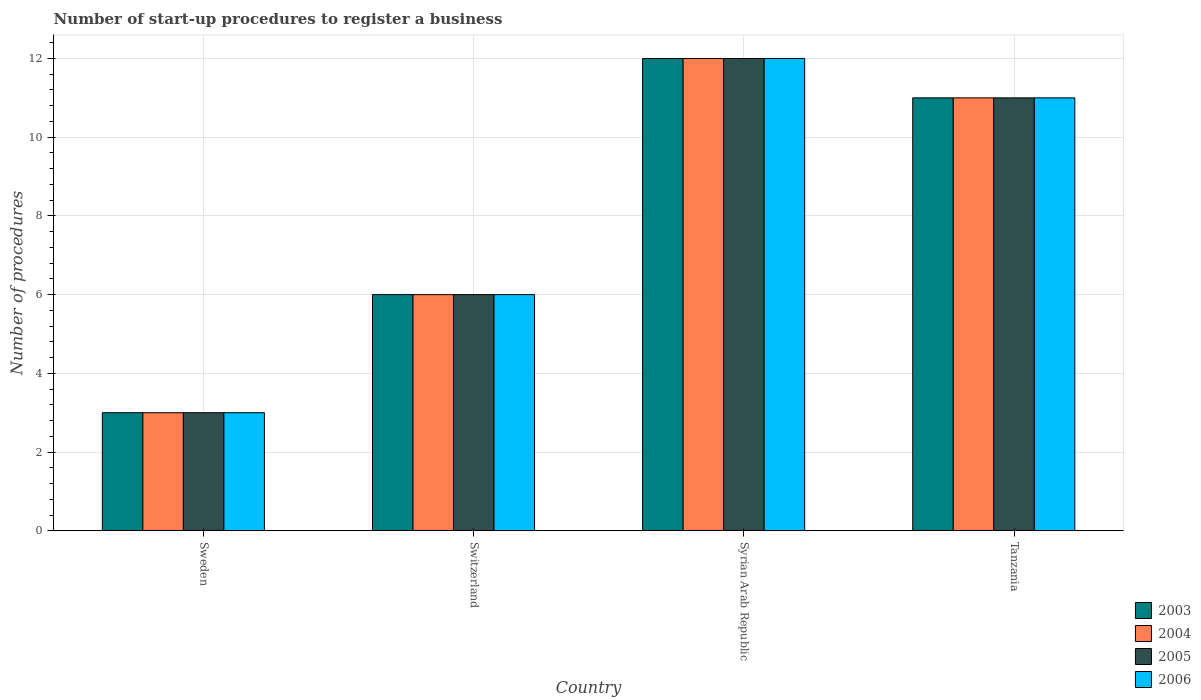Are the number of bars per tick equal to the number of legend labels?
Your answer should be very brief. Yes. How many bars are there on the 4th tick from the right?
Give a very brief answer. 4. What is the label of the 4th group of bars from the left?
Offer a very short reply. Tanzania. In how many cases, is the number of bars for a given country not equal to the number of legend labels?
Make the answer very short. 0. What is the number of procedures required to register a business in 2005 in Syrian Arab Republic?
Provide a succinct answer. 12. Across all countries, what is the maximum number of procedures required to register a business in 2006?
Make the answer very short. 12. In which country was the number of procedures required to register a business in 2005 maximum?
Make the answer very short. Syrian Arab Republic. What is the total number of procedures required to register a business in 2005 in the graph?
Your answer should be compact. 32. What is the difference between the number of procedures required to register a business in 2005 in Tanzania and the number of procedures required to register a business in 2006 in Switzerland?
Your answer should be compact. 5. What is the average number of procedures required to register a business in 2004 per country?
Offer a terse response. 8. What is the difference between the number of procedures required to register a business of/in 2004 and number of procedures required to register a business of/in 2006 in Switzerland?
Offer a very short reply. 0. In how many countries, is the number of procedures required to register a business in 2003 greater than 4.8?
Give a very brief answer. 3. What is the difference between the highest and the second highest number of procedures required to register a business in 2004?
Ensure brevity in your answer.  -1. What does the 1st bar from the right in Switzerland represents?
Your answer should be compact. 2006. Is it the case that in every country, the sum of the number of procedures required to register a business in 2006 and number of procedures required to register a business in 2005 is greater than the number of procedures required to register a business in 2003?
Give a very brief answer. Yes. How many bars are there?
Ensure brevity in your answer.  16. How many countries are there in the graph?
Offer a terse response. 4. What is the difference between two consecutive major ticks on the Y-axis?
Provide a short and direct response. 2. Does the graph contain any zero values?
Ensure brevity in your answer.  No. Does the graph contain grids?
Provide a succinct answer. Yes. Where does the legend appear in the graph?
Offer a very short reply. Bottom right. How many legend labels are there?
Ensure brevity in your answer.  4. What is the title of the graph?
Provide a succinct answer. Number of start-up procedures to register a business. Does "1971" appear as one of the legend labels in the graph?
Provide a succinct answer. No. What is the label or title of the Y-axis?
Provide a succinct answer. Number of procedures. What is the Number of procedures of 2005 in Sweden?
Offer a terse response. 3. What is the Number of procedures in 2003 in Switzerland?
Offer a terse response. 6. What is the Number of procedures of 2005 in Switzerland?
Ensure brevity in your answer.  6. What is the Number of procedures in 2003 in Syrian Arab Republic?
Your answer should be very brief. 12. What is the Number of procedures of 2004 in Syrian Arab Republic?
Your answer should be compact. 12. What is the Number of procedures of 2003 in Tanzania?
Give a very brief answer. 11. Across all countries, what is the maximum Number of procedures in 2004?
Give a very brief answer. 12. Across all countries, what is the maximum Number of procedures of 2006?
Give a very brief answer. 12. Across all countries, what is the minimum Number of procedures of 2003?
Ensure brevity in your answer.  3. Across all countries, what is the minimum Number of procedures of 2004?
Offer a very short reply. 3. Across all countries, what is the minimum Number of procedures of 2005?
Your answer should be compact. 3. What is the total Number of procedures in 2003 in the graph?
Your answer should be very brief. 32. What is the total Number of procedures in 2004 in the graph?
Make the answer very short. 32. What is the difference between the Number of procedures of 2003 in Sweden and that in Switzerland?
Your answer should be very brief. -3. What is the difference between the Number of procedures in 2004 in Sweden and that in Switzerland?
Your answer should be very brief. -3. What is the difference between the Number of procedures in 2006 in Sweden and that in Switzerland?
Your answer should be very brief. -3. What is the difference between the Number of procedures in 2003 in Sweden and that in Syrian Arab Republic?
Make the answer very short. -9. What is the difference between the Number of procedures of 2005 in Sweden and that in Syrian Arab Republic?
Your answer should be very brief. -9. What is the difference between the Number of procedures of 2003 in Sweden and that in Tanzania?
Your answer should be compact. -8. What is the difference between the Number of procedures in 2003 in Switzerland and that in Tanzania?
Offer a terse response. -5. What is the difference between the Number of procedures of 2004 in Switzerland and that in Tanzania?
Provide a succinct answer. -5. What is the difference between the Number of procedures of 2003 in Syrian Arab Republic and that in Tanzania?
Provide a succinct answer. 1. What is the difference between the Number of procedures in 2005 in Syrian Arab Republic and that in Tanzania?
Ensure brevity in your answer.  1. What is the difference between the Number of procedures in 2003 in Sweden and the Number of procedures in 2004 in Switzerland?
Offer a terse response. -3. What is the difference between the Number of procedures of 2003 in Sweden and the Number of procedures of 2005 in Switzerland?
Offer a terse response. -3. What is the difference between the Number of procedures in 2004 in Sweden and the Number of procedures in 2005 in Switzerland?
Offer a very short reply. -3. What is the difference between the Number of procedures in 2003 in Sweden and the Number of procedures in 2005 in Syrian Arab Republic?
Make the answer very short. -9. What is the difference between the Number of procedures in 2004 in Sweden and the Number of procedures in 2005 in Syrian Arab Republic?
Ensure brevity in your answer.  -9. What is the difference between the Number of procedures of 2003 in Sweden and the Number of procedures of 2005 in Tanzania?
Give a very brief answer. -8. What is the difference between the Number of procedures of 2004 in Sweden and the Number of procedures of 2005 in Tanzania?
Your answer should be compact. -8. What is the difference between the Number of procedures in 2004 in Sweden and the Number of procedures in 2006 in Tanzania?
Offer a very short reply. -8. What is the difference between the Number of procedures of 2003 in Switzerland and the Number of procedures of 2004 in Syrian Arab Republic?
Offer a terse response. -6. What is the difference between the Number of procedures of 2003 in Switzerland and the Number of procedures of 2006 in Syrian Arab Republic?
Your response must be concise. -6. What is the difference between the Number of procedures in 2005 in Switzerland and the Number of procedures in 2006 in Syrian Arab Republic?
Ensure brevity in your answer.  -6. What is the difference between the Number of procedures of 2003 in Switzerland and the Number of procedures of 2004 in Tanzania?
Offer a terse response. -5. What is the difference between the Number of procedures in 2004 in Switzerland and the Number of procedures in 2006 in Tanzania?
Provide a succinct answer. -5. What is the difference between the Number of procedures in 2003 in Syrian Arab Republic and the Number of procedures in 2005 in Tanzania?
Your answer should be very brief. 1. What is the difference between the Number of procedures in 2004 in Syrian Arab Republic and the Number of procedures in 2006 in Tanzania?
Provide a short and direct response. 1. What is the difference between the Number of procedures in 2005 in Syrian Arab Republic and the Number of procedures in 2006 in Tanzania?
Keep it short and to the point. 1. What is the average Number of procedures of 2004 per country?
Your answer should be compact. 8. What is the difference between the Number of procedures of 2003 and Number of procedures of 2004 in Sweden?
Give a very brief answer. 0. What is the difference between the Number of procedures of 2003 and Number of procedures of 2005 in Sweden?
Provide a succinct answer. 0. What is the difference between the Number of procedures in 2003 and Number of procedures in 2006 in Sweden?
Provide a short and direct response. 0. What is the difference between the Number of procedures in 2004 and Number of procedures in 2005 in Sweden?
Ensure brevity in your answer.  0. What is the difference between the Number of procedures of 2004 and Number of procedures of 2006 in Sweden?
Provide a short and direct response. 0. What is the difference between the Number of procedures in 2003 and Number of procedures in 2005 in Switzerland?
Ensure brevity in your answer.  0. What is the difference between the Number of procedures of 2004 and Number of procedures of 2005 in Switzerland?
Provide a succinct answer. 0. What is the difference between the Number of procedures of 2004 and Number of procedures of 2006 in Switzerland?
Provide a short and direct response. 0. What is the difference between the Number of procedures of 2004 and Number of procedures of 2005 in Syrian Arab Republic?
Give a very brief answer. 0. What is the difference between the Number of procedures of 2004 and Number of procedures of 2006 in Syrian Arab Republic?
Provide a short and direct response. 0. What is the difference between the Number of procedures in 2005 and Number of procedures in 2006 in Syrian Arab Republic?
Keep it short and to the point. 0. What is the difference between the Number of procedures in 2004 and Number of procedures in 2006 in Tanzania?
Provide a short and direct response. 0. What is the ratio of the Number of procedures in 2005 in Sweden to that in Switzerland?
Provide a succinct answer. 0.5. What is the ratio of the Number of procedures of 2003 in Sweden to that in Syrian Arab Republic?
Give a very brief answer. 0.25. What is the ratio of the Number of procedures in 2004 in Sweden to that in Syrian Arab Republic?
Your answer should be compact. 0.25. What is the ratio of the Number of procedures of 2006 in Sweden to that in Syrian Arab Republic?
Your answer should be compact. 0.25. What is the ratio of the Number of procedures in 2003 in Sweden to that in Tanzania?
Ensure brevity in your answer.  0.27. What is the ratio of the Number of procedures of 2004 in Sweden to that in Tanzania?
Ensure brevity in your answer.  0.27. What is the ratio of the Number of procedures in 2005 in Sweden to that in Tanzania?
Make the answer very short. 0.27. What is the ratio of the Number of procedures of 2006 in Sweden to that in Tanzania?
Provide a short and direct response. 0.27. What is the ratio of the Number of procedures in 2004 in Switzerland to that in Syrian Arab Republic?
Offer a terse response. 0.5. What is the ratio of the Number of procedures in 2005 in Switzerland to that in Syrian Arab Republic?
Your answer should be very brief. 0.5. What is the ratio of the Number of procedures in 2006 in Switzerland to that in Syrian Arab Republic?
Offer a very short reply. 0.5. What is the ratio of the Number of procedures of 2003 in Switzerland to that in Tanzania?
Make the answer very short. 0.55. What is the ratio of the Number of procedures in 2004 in Switzerland to that in Tanzania?
Offer a very short reply. 0.55. What is the ratio of the Number of procedures in 2005 in Switzerland to that in Tanzania?
Your answer should be compact. 0.55. What is the ratio of the Number of procedures in 2006 in Switzerland to that in Tanzania?
Offer a very short reply. 0.55. What is the difference between the highest and the second highest Number of procedures in 2003?
Provide a short and direct response. 1. What is the difference between the highest and the second highest Number of procedures of 2005?
Ensure brevity in your answer.  1. What is the difference between the highest and the lowest Number of procedures of 2004?
Offer a terse response. 9. What is the difference between the highest and the lowest Number of procedures in 2006?
Offer a terse response. 9. 